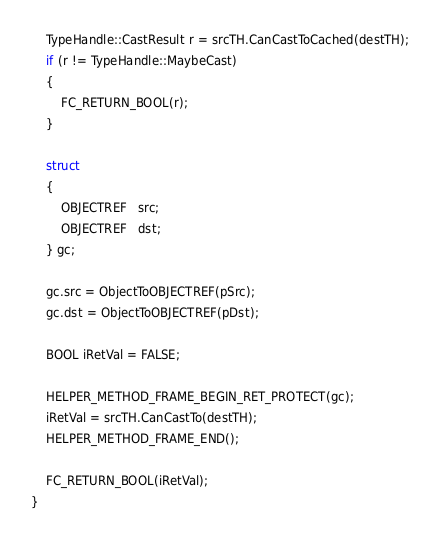Convert code to text. <code><loc_0><loc_0><loc_500><loc_500><_C++_>
    TypeHandle::CastResult r = srcTH.CanCastToCached(destTH);
    if (r != TypeHandle::MaybeCast)
    {
        FC_RETURN_BOOL(r);
    }

    struct
    {
        OBJECTREF   src;
        OBJECTREF   dst;
    } gc;

    gc.src = ObjectToOBJECTREF(pSrc);
    gc.dst = ObjectToOBJECTREF(pDst);

    BOOL iRetVal = FALSE;

    HELPER_METHOD_FRAME_BEGIN_RET_PROTECT(gc);
    iRetVal = srcTH.CanCastTo(destTH);
    HELPER_METHOD_FRAME_END();

    FC_RETURN_BOOL(iRetVal);
}</code> 